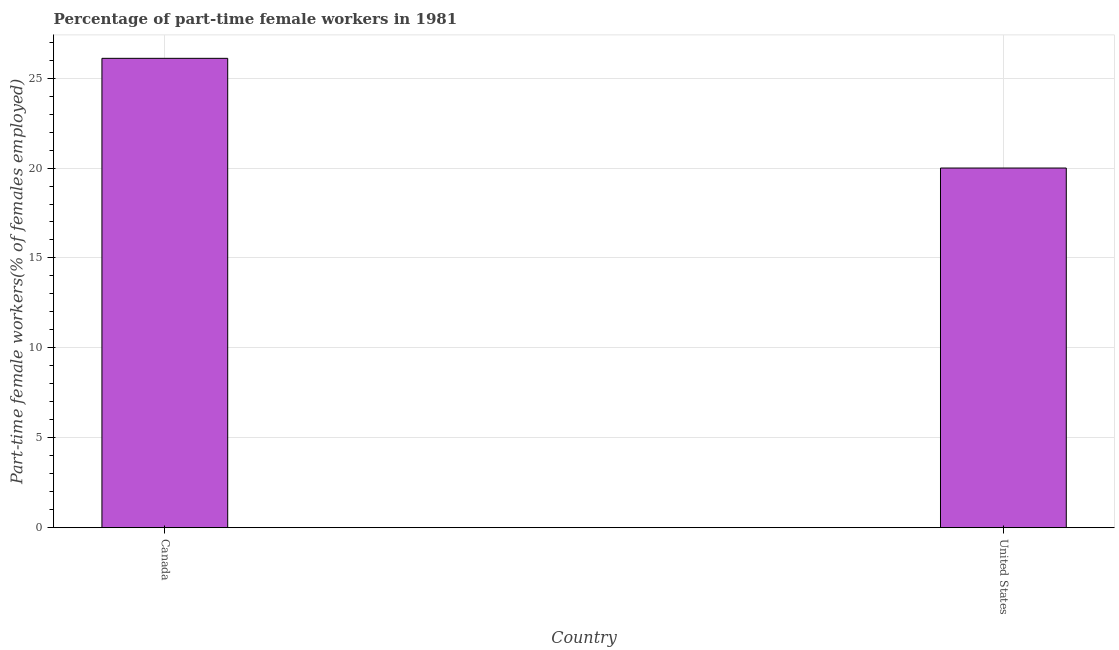Does the graph contain any zero values?
Offer a very short reply. No. Does the graph contain grids?
Your answer should be compact. Yes. What is the title of the graph?
Offer a terse response. Percentage of part-time female workers in 1981. What is the label or title of the Y-axis?
Give a very brief answer. Part-time female workers(% of females employed). What is the percentage of part-time female workers in Canada?
Provide a succinct answer. 26.1. Across all countries, what is the maximum percentage of part-time female workers?
Offer a terse response. 26.1. In which country was the percentage of part-time female workers maximum?
Your response must be concise. Canada. What is the sum of the percentage of part-time female workers?
Offer a very short reply. 46.1. What is the difference between the percentage of part-time female workers in Canada and United States?
Make the answer very short. 6.1. What is the average percentage of part-time female workers per country?
Keep it short and to the point. 23.05. What is the median percentage of part-time female workers?
Make the answer very short. 23.05. In how many countries, is the percentage of part-time female workers greater than 7 %?
Give a very brief answer. 2. What is the ratio of the percentage of part-time female workers in Canada to that in United States?
Ensure brevity in your answer.  1.3. What is the Part-time female workers(% of females employed) of Canada?
Offer a terse response. 26.1. What is the Part-time female workers(% of females employed) in United States?
Your answer should be compact. 20. What is the ratio of the Part-time female workers(% of females employed) in Canada to that in United States?
Provide a succinct answer. 1.3. 